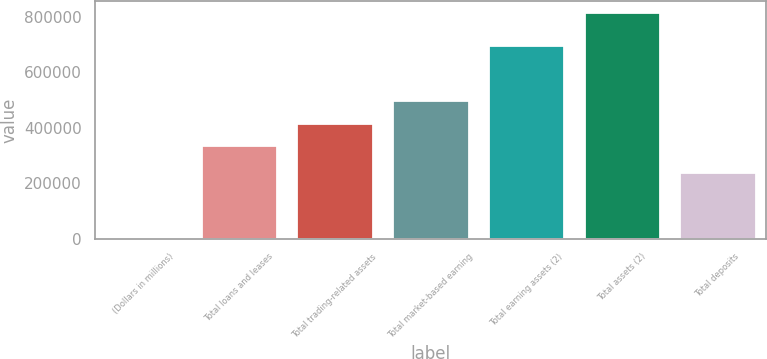Convert chart. <chart><loc_0><loc_0><loc_500><loc_500><bar_chart><fcel>(Dollars in millions)<fcel>Total loans and leases<fcel>Total trading-related assets<fcel>Total market-based earning<fcel>Total earning assets (2)<fcel>Total assets (2)<fcel>Total deposits<nl><fcel>2008<fcel>337352<fcel>418834<fcel>500317<fcel>699708<fcel>816832<fcel>239097<nl></chart> 